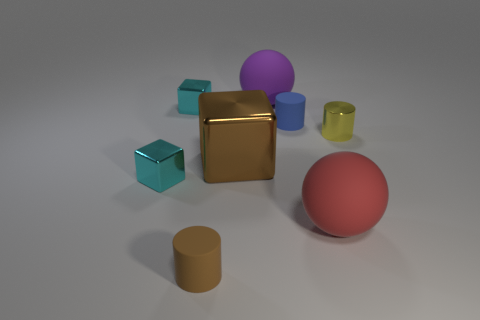The shiny thing that is the same shape as the blue matte object is what color?
Give a very brief answer. Yellow. Is there any other thing that is the same shape as the tiny brown thing?
Give a very brief answer. Yes. Does the tiny shiny thing that is in front of the yellow cylinder have the same color as the large block?
Your response must be concise. No. What size is the yellow object that is the same shape as the small brown thing?
Offer a terse response. Small. How many red things are the same material as the brown cylinder?
Keep it short and to the point. 1. There is a matte cylinder in front of the small metal thing that is to the right of the red rubber sphere; are there any big purple matte balls that are on the left side of it?
Keep it short and to the point. No. There is a purple matte thing; what shape is it?
Offer a terse response. Sphere. Do the big sphere on the right side of the large purple sphere and the tiny cylinder in front of the brown metal object have the same material?
Your response must be concise. Yes. How many things have the same color as the metallic cylinder?
Provide a short and direct response. 0. What shape is the object that is both behind the brown metal block and on the right side of the blue rubber cylinder?
Give a very brief answer. Cylinder. 